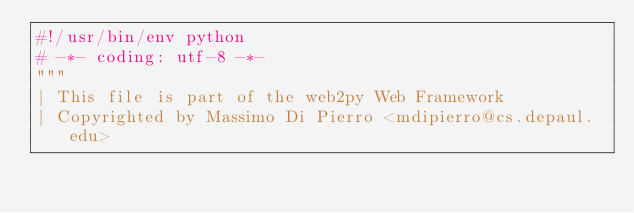Convert code to text. <code><loc_0><loc_0><loc_500><loc_500><_Python_>#!/usr/bin/env python
# -*- coding: utf-8 -*-
"""
| This file is part of the web2py Web Framework
| Copyrighted by Massimo Di Pierro <mdipierro@cs.depaul.edu></code> 